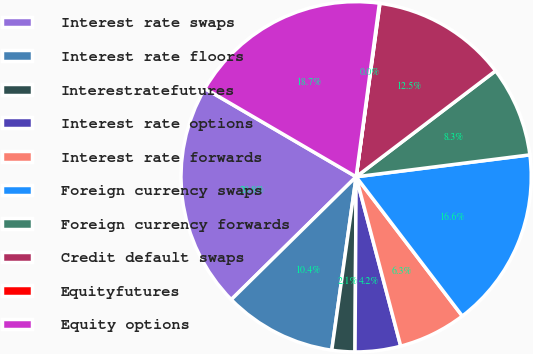Convert chart to OTSL. <chart><loc_0><loc_0><loc_500><loc_500><pie_chart><fcel>Interest rate swaps<fcel>Interest rate floors<fcel>Interestratefutures<fcel>Interest rate options<fcel>Interest rate forwards<fcel>Foreign currency swaps<fcel>Foreign currency forwards<fcel>Credit default swaps<fcel>Equityfutures<fcel>Equity options<nl><fcel>20.78%<fcel>10.41%<fcel>2.12%<fcel>4.2%<fcel>6.27%<fcel>16.63%<fcel>8.34%<fcel>12.49%<fcel>0.05%<fcel>18.71%<nl></chart> 